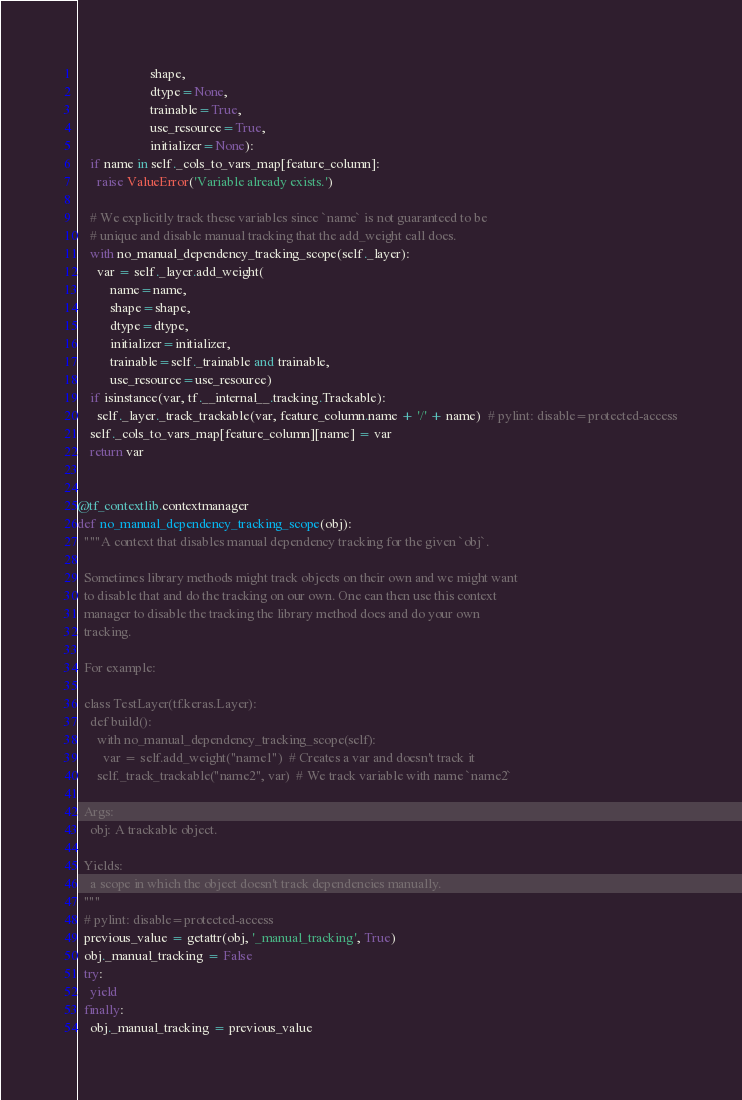Convert code to text. <code><loc_0><loc_0><loc_500><loc_500><_Python_>                      shape,
                      dtype=None,
                      trainable=True,
                      use_resource=True,
                      initializer=None):
    if name in self._cols_to_vars_map[feature_column]:
      raise ValueError('Variable already exists.')

    # We explicitly track these variables since `name` is not guaranteed to be
    # unique and disable manual tracking that the add_weight call does.
    with no_manual_dependency_tracking_scope(self._layer):
      var = self._layer.add_weight(
          name=name,
          shape=shape,
          dtype=dtype,
          initializer=initializer,
          trainable=self._trainable and trainable,
          use_resource=use_resource)
    if isinstance(var, tf.__internal__.tracking.Trackable):
      self._layer._track_trackable(var, feature_column.name + '/' + name)  # pylint: disable=protected-access
    self._cols_to_vars_map[feature_column][name] = var
    return var


@tf_contextlib.contextmanager
def no_manual_dependency_tracking_scope(obj):
  """A context that disables manual dependency tracking for the given `obj`.

  Sometimes library methods might track objects on their own and we might want
  to disable that and do the tracking on our own. One can then use this context
  manager to disable the tracking the library method does and do your own
  tracking.

  For example:

  class TestLayer(tf.keras.Layer):
    def build():
      with no_manual_dependency_tracking_scope(self):
        var = self.add_weight("name1")  # Creates a var and doesn't track it
      self._track_trackable("name2", var)  # We track variable with name `name2`

  Args:
    obj: A trackable object.

  Yields:
    a scope in which the object doesn't track dependencies manually.
  """
  # pylint: disable=protected-access
  previous_value = getattr(obj, '_manual_tracking', True)
  obj._manual_tracking = False
  try:
    yield
  finally:
    obj._manual_tracking = previous_value
</code> 